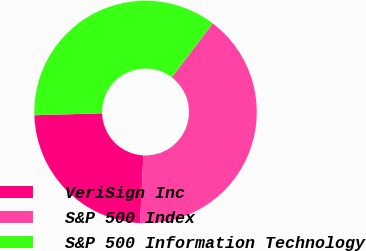Convert chart to OTSL. <chart><loc_0><loc_0><loc_500><loc_500><pie_chart><fcel>VeriSign Inc<fcel>S&P 500 Index<fcel>S&P 500 Information Technology<nl><fcel>23.75%<fcel>40.47%<fcel>35.79%<nl></chart> 